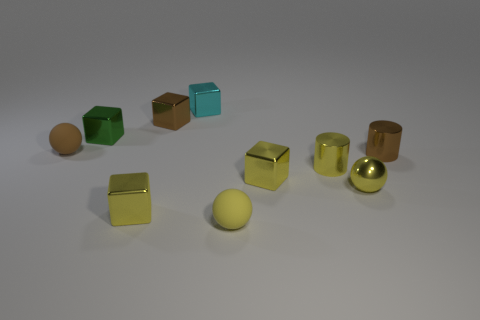Subtract all tiny green metal blocks. How many blocks are left? 4 Subtract all red cylinders. How many yellow cubes are left? 2 Subtract all yellow cubes. How many cubes are left? 3 Subtract all balls. How many objects are left? 7 Subtract 1 spheres. How many spheres are left? 2 Subtract 0 purple cubes. How many objects are left? 10 Subtract all gray cylinders. Subtract all yellow balls. How many cylinders are left? 2 Subtract all small cyan shiny objects. Subtract all brown rubber objects. How many objects are left? 8 Add 1 small blocks. How many small blocks are left? 6 Add 6 big yellow blocks. How many big yellow blocks exist? 6 